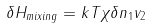Convert formula to latex. <formula><loc_0><loc_0><loc_500><loc_500>\delta H _ { m i x i n g } = k T \chi \delta n _ { 1 } v _ { 2 }</formula> 